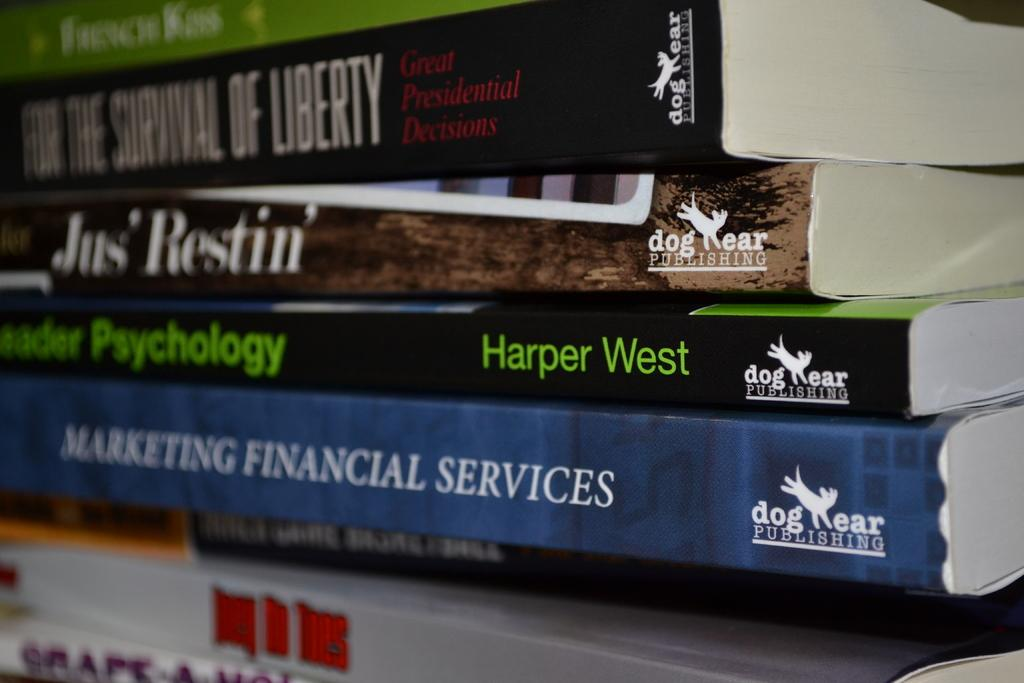<image>
Summarize the visual content of the image. Many books stacked on top of each other one of them by Harper West. 